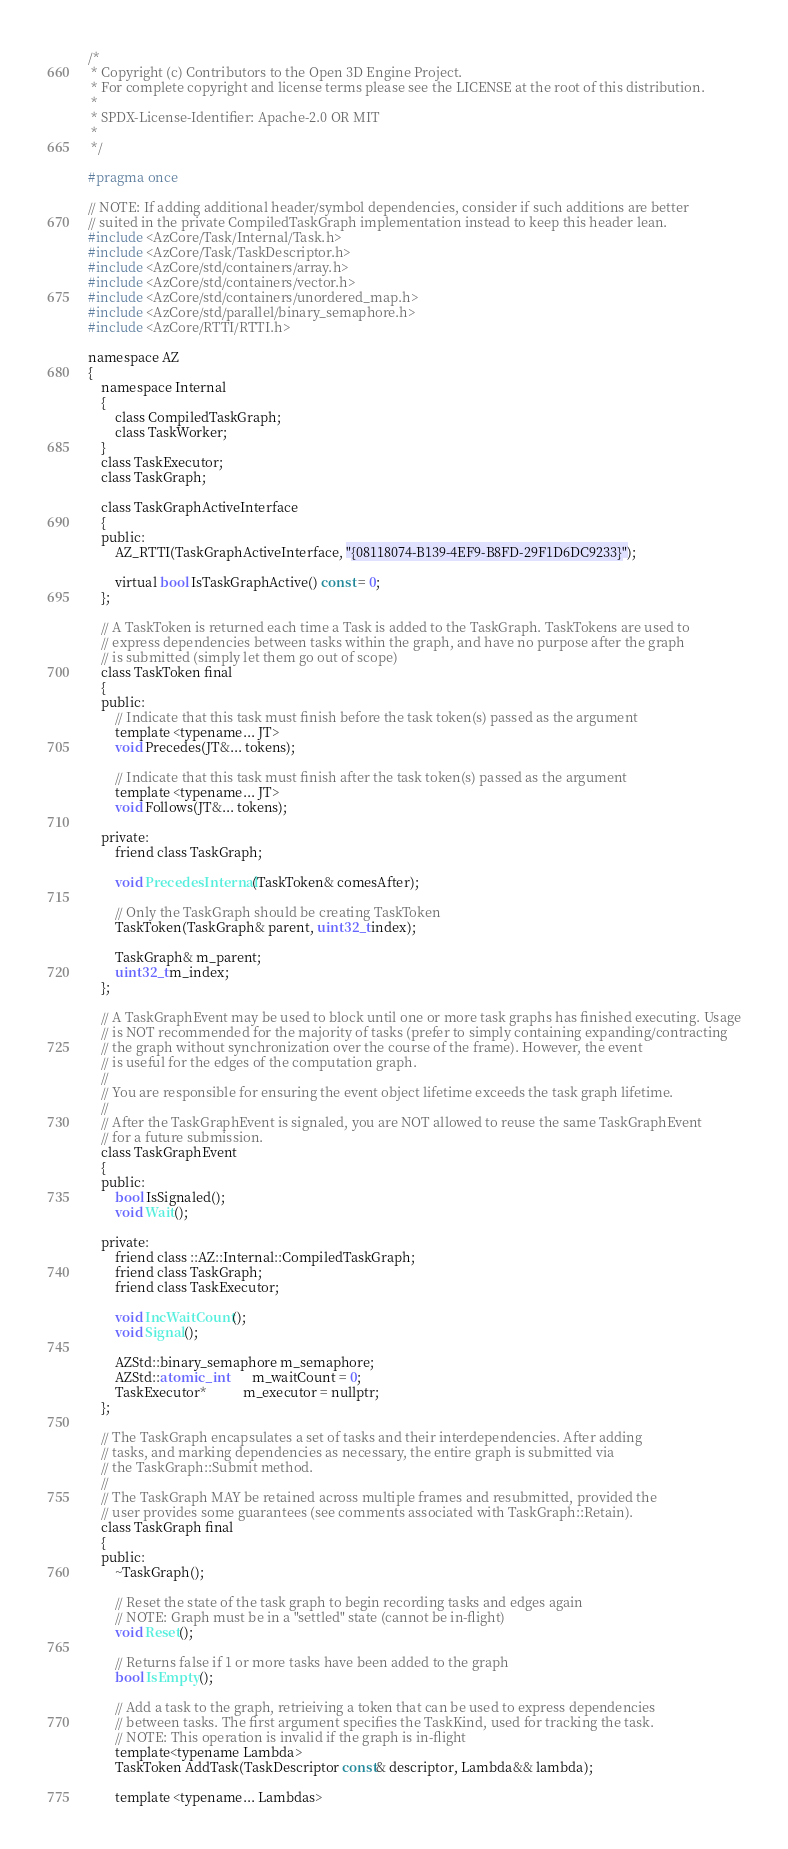Convert code to text. <code><loc_0><loc_0><loc_500><loc_500><_C_>/*
 * Copyright (c) Contributors to the Open 3D Engine Project.
 * For complete copyright and license terms please see the LICENSE at the root of this distribution.
 *
 * SPDX-License-Identifier: Apache-2.0 OR MIT
 *
 */

#pragma once

// NOTE: If adding additional header/symbol dependencies, consider if such additions are better
// suited in the private CompiledTaskGraph implementation instead to keep this header lean.
#include <AzCore/Task/Internal/Task.h>
#include <AzCore/Task/TaskDescriptor.h>
#include <AzCore/std/containers/array.h>
#include <AzCore/std/containers/vector.h>
#include <AzCore/std/containers/unordered_map.h>
#include <AzCore/std/parallel/binary_semaphore.h>
#include <AzCore/RTTI/RTTI.h>

namespace AZ
{
    namespace Internal
    {
        class CompiledTaskGraph;
        class TaskWorker;
    }
    class TaskExecutor;
    class TaskGraph;

    class TaskGraphActiveInterface
    {
    public:
        AZ_RTTI(TaskGraphActiveInterface, "{08118074-B139-4EF9-B8FD-29F1D6DC9233}");

        virtual bool IsTaskGraphActive() const = 0;
    };

    // A TaskToken is returned each time a Task is added to the TaskGraph. TaskTokens are used to
    // express dependencies between tasks within the graph, and have no purpose after the graph
    // is submitted (simply let them go out of scope)
    class TaskToken final
    {
    public:
        // Indicate that this task must finish before the task token(s) passed as the argument
        template <typename... JT>
        void Precedes(JT&... tokens);

        // Indicate that this task must finish after the task token(s) passed as the argument
        template <typename... JT>
        void Follows(JT&... tokens);

    private:
        friend class TaskGraph;

        void PrecedesInternal(TaskToken& comesAfter);

        // Only the TaskGraph should be creating TaskToken
        TaskToken(TaskGraph& parent, uint32_t index);

        TaskGraph& m_parent;
        uint32_t m_index;
    };

    // A TaskGraphEvent may be used to block until one or more task graphs has finished executing. Usage
    // is NOT recommended for the majority of tasks (prefer to simply containing expanding/contracting
    // the graph without synchronization over the course of the frame). However, the event
    // is useful for the edges of the computation graph.
    //
    // You are responsible for ensuring the event object lifetime exceeds the task graph lifetime.
    //
    // After the TaskGraphEvent is signaled, you are NOT allowed to reuse the same TaskGraphEvent
    // for a future submission.
    class TaskGraphEvent
    {
    public:
        bool IsSignaled();
        void Wait();

    private:
        friend class ::AZ::Internal::CompiledTaskGraph;
        friend class TaskGraph;
        friend class TaskExecutor;

        void IncWaitCount();
        void Signal();

        AZStd::binary_semaphore m_semaphore;
        AZStd::atomic_int       m_waitCount = 0;
        TaskExecutor*           m_executor = nullptr;
    };

    // The TaskGraph encapsulates a set of tasks and their interdependencies. After adding
    // tasks, and marking dependencies as necessary, the entire graph is submitted via
    // the TaskGraph::Submit method.
    //
    // The TaskGraph MAY be retained across multiple frames and resubmitted, provided the
    // user provides some guarantees (see comments associated with TaskGraph::Retain).
    class TaskGraph final
    {
    public:
        ~TaskGraph();

        // Reset the state of the task graph to begin recording tasks and edges again
        // NOTE: Graph must be in a "settled" state (cannot be in-flight)
        void Reset();
        
        // Returns false if 1 or more tasks have been added to the graph
        bool IsEmpty();

        // Add a task to the graph, retrieiving a token that can be used to express dependencies
        // between tasks. The first argument specifies the TaskKind, used for tracking the task.
        // NOTE: This operation is invalid if the graph is in-flight
        template<typename Lambda>
        TaskToken AddTask(TaskDescriptor const& descriptor, Lambda&& lambda);

        template <typename... Lambdas></code> 